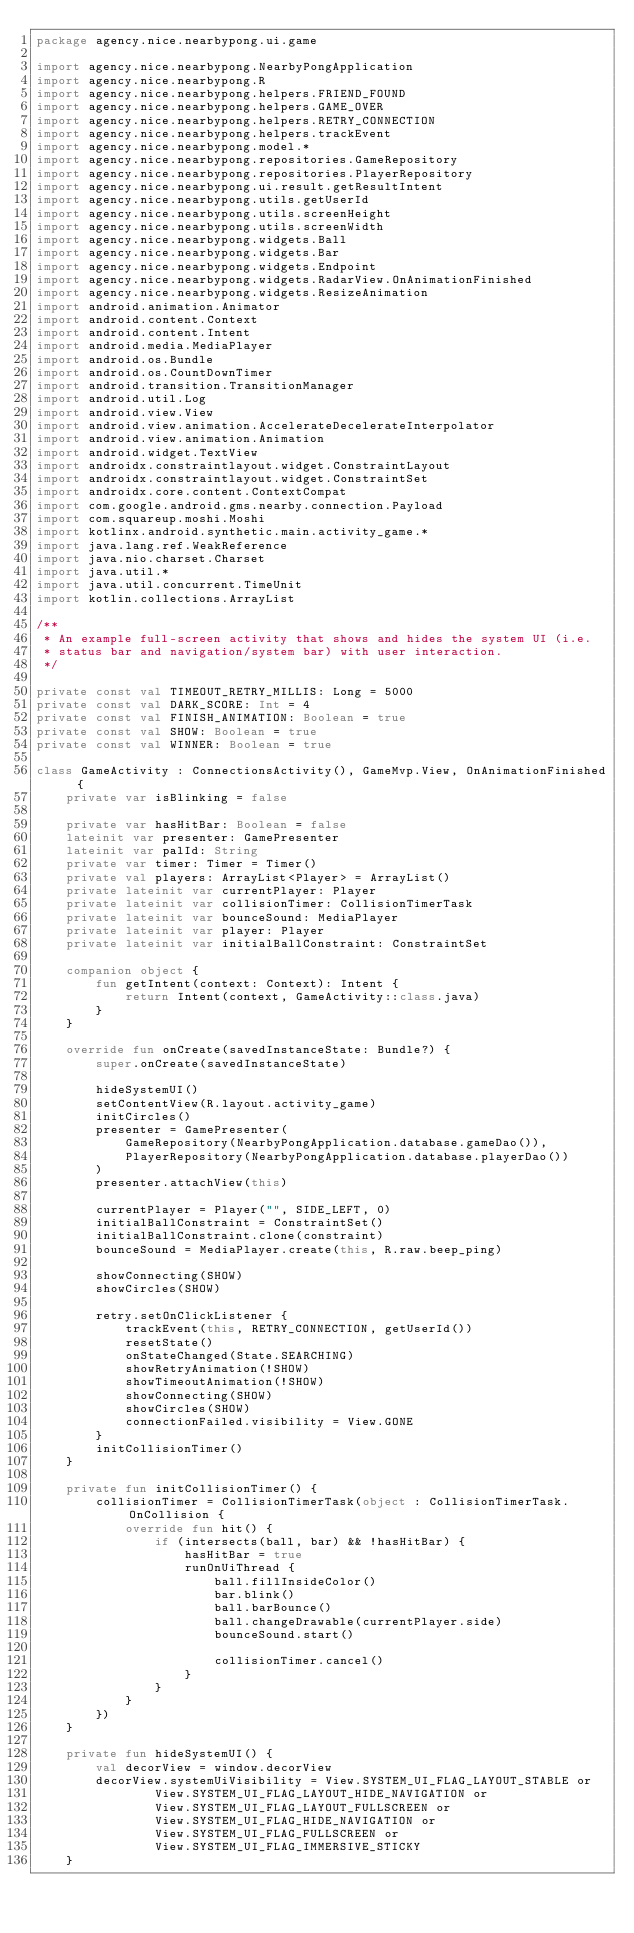Convert code to text. <code><loc_0><loc_0><loc_500><loc_500><_Kotlin_>package agency.nice.nearbypong.ui.game

import agency.nice.nearbypong.NearbyPongApplication
import agency.nice.nearbypong.R
import agency.nice.nearbypong.helpers.FRIEND_FOUND
import agency.nice.nearbypong.helpers.GAME_OVER
import agency.nice.nearbypong.helpers.RETRY_CONNECTION
import agency.nice.nearbypong.helpers.trackEvent
import agency.nice.nearbypong.model.*
import agency.nice.nearbypong.repositories.GameRepository
import agency.nice.nearbypong.repositories.PlayerRepository
import agency.nice.nearbypong.ui.result.getResultIntent
import agency.nice.nearbypong.utils.getUserId
import agency.nice.nearbypong.utils.screenHeight
import agency.nice.nearbypong.utils.screenWidth
import agency.nice.nearbypong.widgets.Ball
import agency.nice.nearbypong.widgets.Bar
import agency.nice.nearbypong.widgets.Endpoint
import agency.nice.nearbypong.widgets.RadarView.OnAnimationFinished
import agency.nice.nearbypong.widgets.ResizeAnimation
import android.animation.Animator
import android.content.Context
import android.content.Intent
import android.media.MediaPlayer
import android.os.Bundle
import android.os.CountDownTimer
import android.transition.TransitionManager
import android.util.Log
import android.view.View
import android.view.animation.AccelerateDecelerateInterpolator
import android.view.animation.Animation
import android.widget.TextView
import androidx.constraintlayout.widget.ConstraintLayout
import androidx.constraintlayout.widget.ConstraintSet
import androidx.core.content.ContextCompat
import com.google.android.gms.nearby.connection.Payload
import com.squareup.moshi.Moshi
import kotlinx.android.synthetic.main.activity_game.*
import java.lang.ref.WeakReference
import java.nio.charset.Charset
import java.util.*
import java.util.concurrent.TimeUnit
import kotlin.collections.ArrayList

/**
 * An example full-screen activity that shows and hides the system UI (i.e.
 * status bar and navigation/system bar) with user interaction.
 */

private const val TIMEOUT_RETRY_MILLIS: Long = 5000
private const val DARK_SCORE: Int = 4
private const val FINISH_ANIMATION: Boolean = true
private const val SHOW: Boolean = true
private const val WINNER: Boolean = true

class GameActivity : ConnectionsActivity(), GameMvp.View, OnAnimationFinished {
    private var isBlinking = false

    private var hasHitBar: Boolean = false
    lateinit var presenter: GamePresenter
    lateinit var palId: String
    private var timer: Timer = Timer()
    private val players: ArrayList<Player> = ArrayList()
    private lateinit var currentPlayer: Player
    private lateinit var collisionTimer: CollisionTimerTask
    private lateinit var bounceSound: MediaPlayer
    private lateinit var player: Player
    private lateinit var initialBallConstraint: ConstraintSet

    companion object {
        fun getIntent(context: Context): Intent {
            return Intent(context, GameActivity::class.java)
        }
    }

    override fun onCreate(savedInstanceState: Bundle?) {
        super.onCreate(savedInstanceState)

        hideSystemUI()
        setContentView(R.layout.activity_game)
        initCircles()
        presenter = GamePresenter(
            GameRepository(NearbyPongApplication.database.gameDao()),
            PlayerRepository(NearbyPongApplication.database.playerDao())
        )
        presenter.attachView(this)

        currentPlayer = Player("", SIDE_LEFT, 0)
        initialBallConstraint = ConstraintSet()
        initialBallConstraint.clone(constraint)
        bounceSound = MediaPlayer.create(this, R.raw.beep_ping)

        showConnecting(SHOW)
        showCircles(SHOW)

        retry.setOnClickListener {
            trackEvent(this, RETRY_CONNECTION, getUserId())
            resetState()
            onStateChanged(State.SEARCHING)
            showRetryAnimation(!SHOW)
            showTimeoutAnimation(!SHOW)
            showConnecting(SHOW)
            showCircles(SHOW)
            connectionFailed.visibility = View.GONE
        }
        initCollisionTimer()
    }

    private fun initCollisionTimer() {
        collisionTimer = CollisionTimerTask(object : CollisionTimerTask.OnCollision {
            override fun hit() {
                if (intersects(ball, bar) && !hasHitBar) {
                    hasHitBar = true
                    runOnUiThread {
                        ball.fillInsideColor()
                        bar.blink()
                        ball.barBounce()
                        ball.changeDrawable(currentPlayer.side)
                        bounceSound.start()

                        collisionTimer.cancel()
                    }
                }
            }
        })
    }

    private fun hideSystemUI() {
        val decorView = window.decorView
        decorView.systemUiVisibility = View.SYSTEM_UI_FLAG_LAYOUT_STABLE or
                View.SYSTEM_UI_FLAG_LAYOUT_HIDE_NAVIGATION or
                View.SYSTEM_UI_FLAG_LAYOUT_FULLSCREEN or
                View.SYSTEM_UI_FLAG_HIDE_NAVIGATION or
                View.SYSTEM_UI_FLAG_FULLSCREEN or
                View.SYSTEM_UI_FLAG_IMMERSIVE_STICKY
    }
</code> 